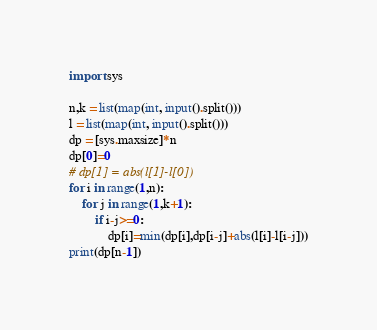<code> <loc_0><loc_0><loc_500><loc_500><_Python_>import sys

n,k = list(map(int, input().split()))
l = list(map(int, input().split()))
dp = [sys.maxsize]*n
dp[0]=0
# dp[1] = abs(l[1]-l[0])
for i in range(1,n):
    for j in range(1,k+1):
        if i-j>=0:
            dp[i]=min(dp[i],dp[i-j]+abs(l[i]-l[i-j]))
print(dp[n-1])</code> 